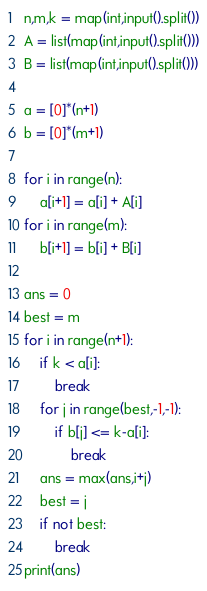<code> <loc_0><loc_0><loc_500><loc_500><_Python_>n,m,k = map(int,input().split())
A = list(map(int,input().split()))
B = list(map(int,input().split()))

a = [0]*(n+1)
b = [0]*(m+1)

for i in range(n):
    a[i+1] = a[i] + A[i]
for i in range(m):
    b[i+1] = b[i] + B[i]

ans = 0
best = m
for i in range(n+1):
    if k < a[i]:
        break
    for j in range(best,-1,-1):
        if b[j] <= k-a[i]:
            break
    ans = max(ans,i+j)
    best = j
    if not best:
        break
print(ans)</code> 